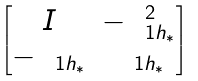<formula> <loc_0><loc_0><loc_500><loc_500>\begin{bmatrix} I & - { \mathbf \Lambda } _ { 1 { h _ { * } } } ^ { 2 } \\ - { \mathbf \Lambda } _ { 1 { h _ { * } } } & { \mathbf \Lambda } _ { 1 { h _ { * } } } \end{bmatrix}</formula> 